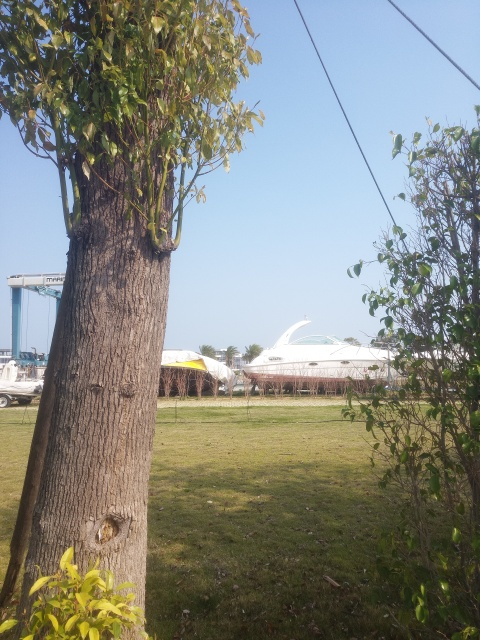Describe the overall atmosphere of the scene depicted in the image. The image conveys a serene and leisurely atmosphere with a clear sky, green foliage, and a distant yacht suggesting a peaceful coastal setting. The presence of the tree in the foreground and the grassy area add a natural and calming element to the scene. 